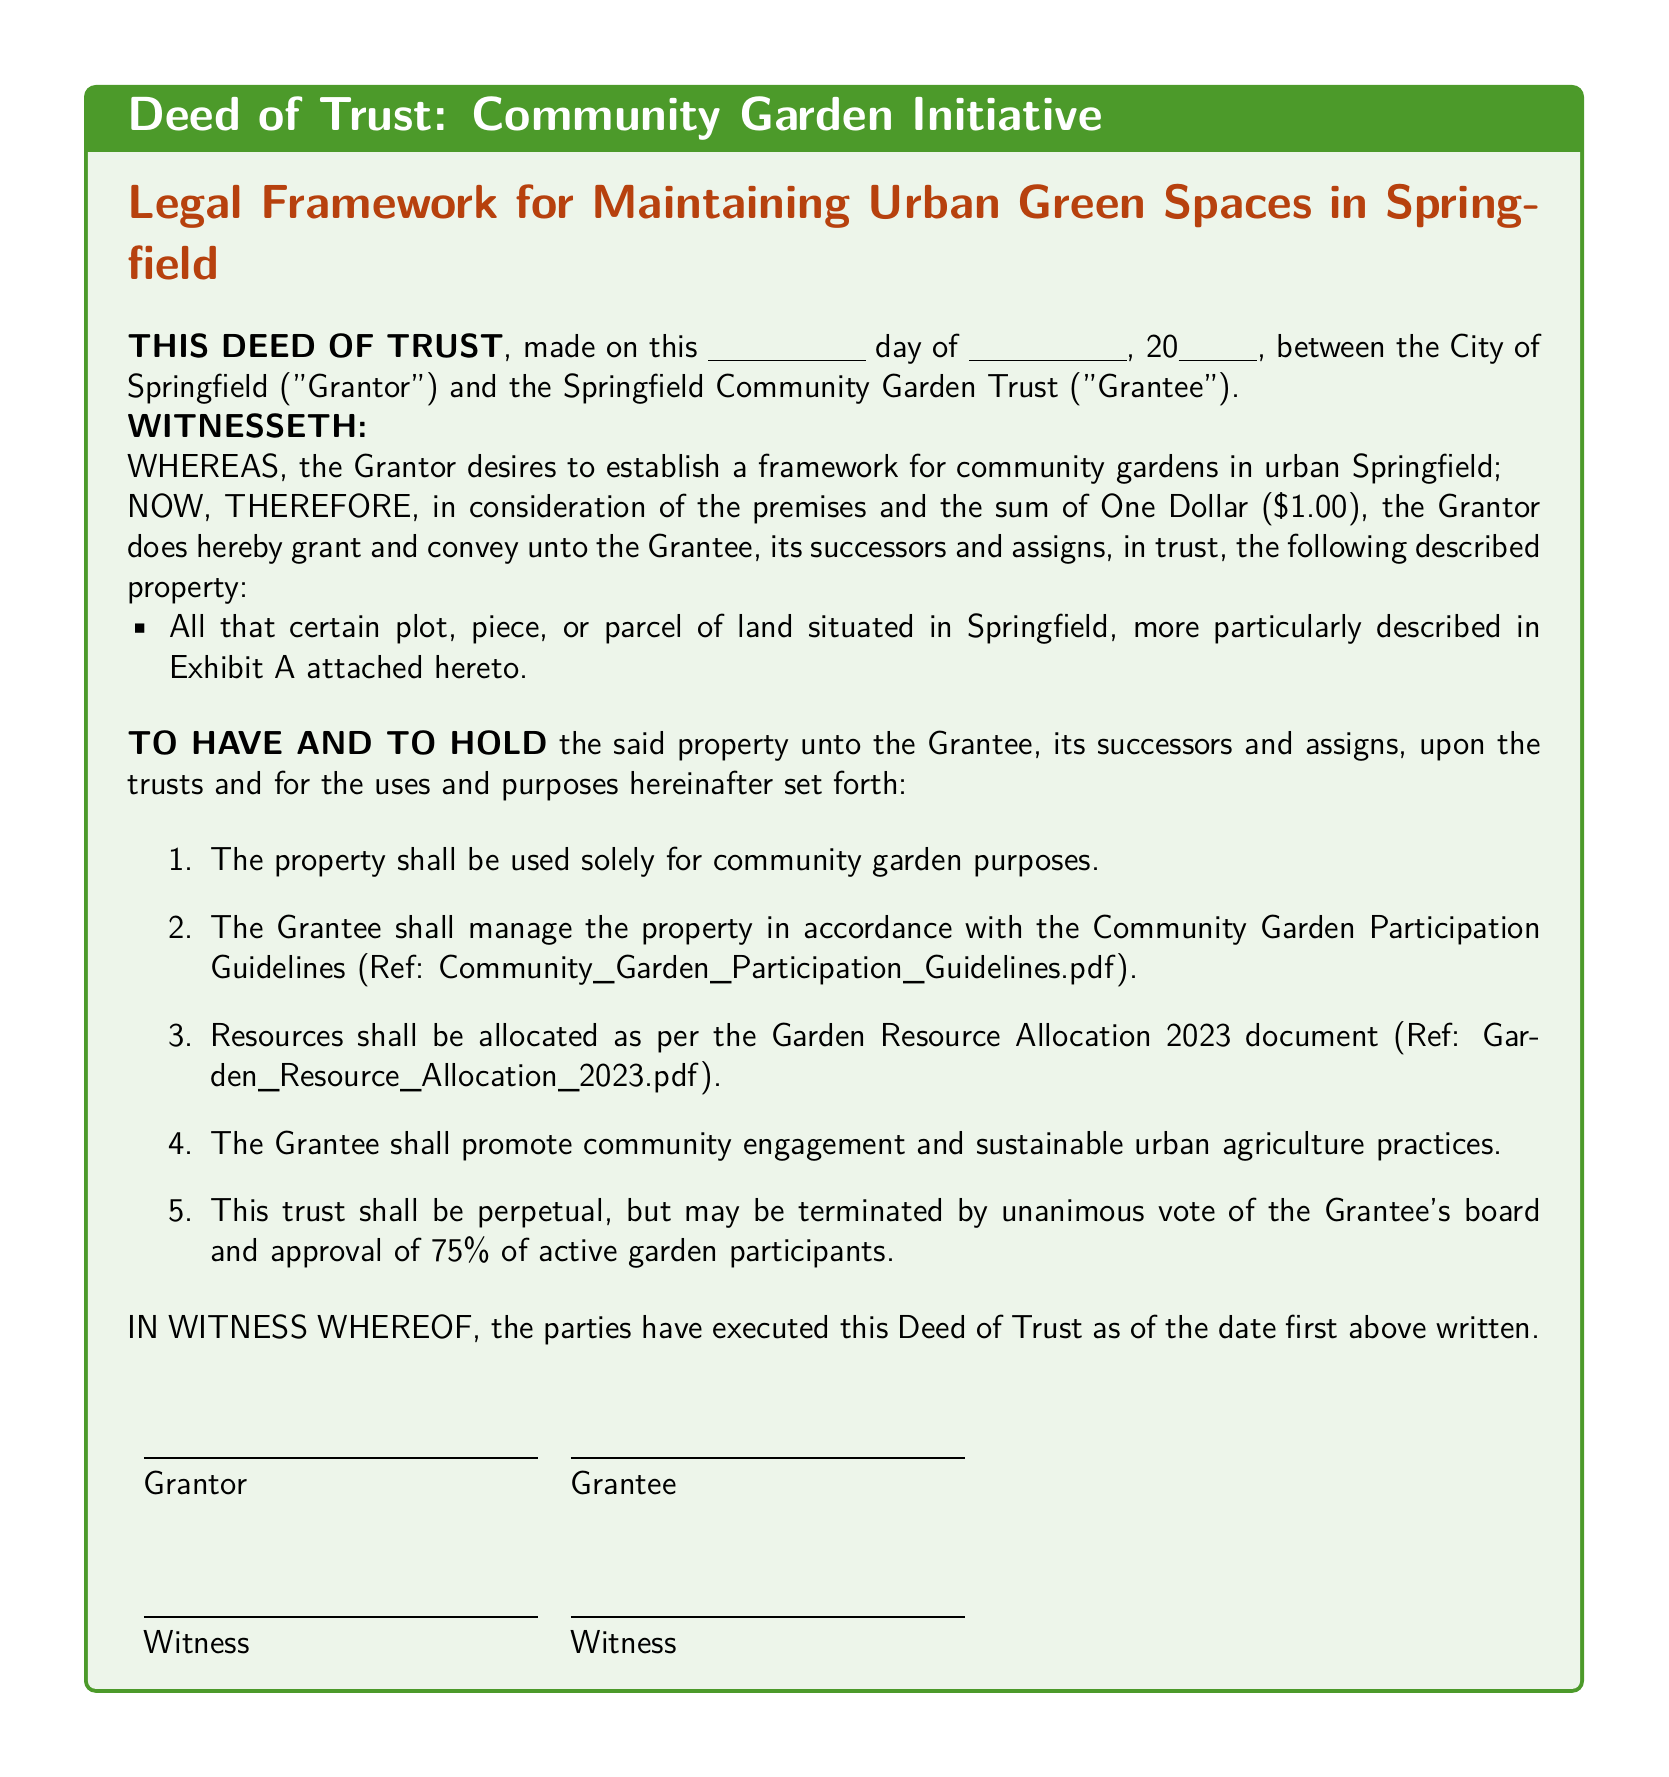What is the date mentioned in the deed? The deed specifies a day and month, followed by a year, formatted as "this \_\_\_ day of \_\_\_, 20\_\_\_."
Answer: Not specified Who are the parties involved in the deed? The deed lists the City of Springfield as the Grantor and the Springfield Community Garden Trust as the Grantee.
Answer: City of Springfield and Springfield Community Garden Trust What is the total consideration amount mentioned? The consideration amount for the deed is stated to be One Dollar.
Answer: One Dollar What is the purpose of the granted property? The property is to be used solely for community garden purposes, as stated in the first clause of the deed.
Answer: Community garden purposes What percentage of active garden participants is needed to terminate the trust? The deed specifies that a 75% approval from active garden participants is required for the termination of the trust.
Answer: 75% What type of guidelines must the Grantee follow in managing the property? The Grantee is required to manage the property according to the Community Garden Participation Guidelines.
Answer: Community Garden Participation Guidelines What is the nature of the trust conveyed in the deed? The trust is described as perpetual but may be terminated under certain conditions.
Answer: Perpetual What is the legal document type for this initiative? The document is specifically titled a Deed of Trust.
Answer: Deed of Trust What year are the resource allocations referenced in? The resource allocations are specified for the year 2023.
Answer: 2023 